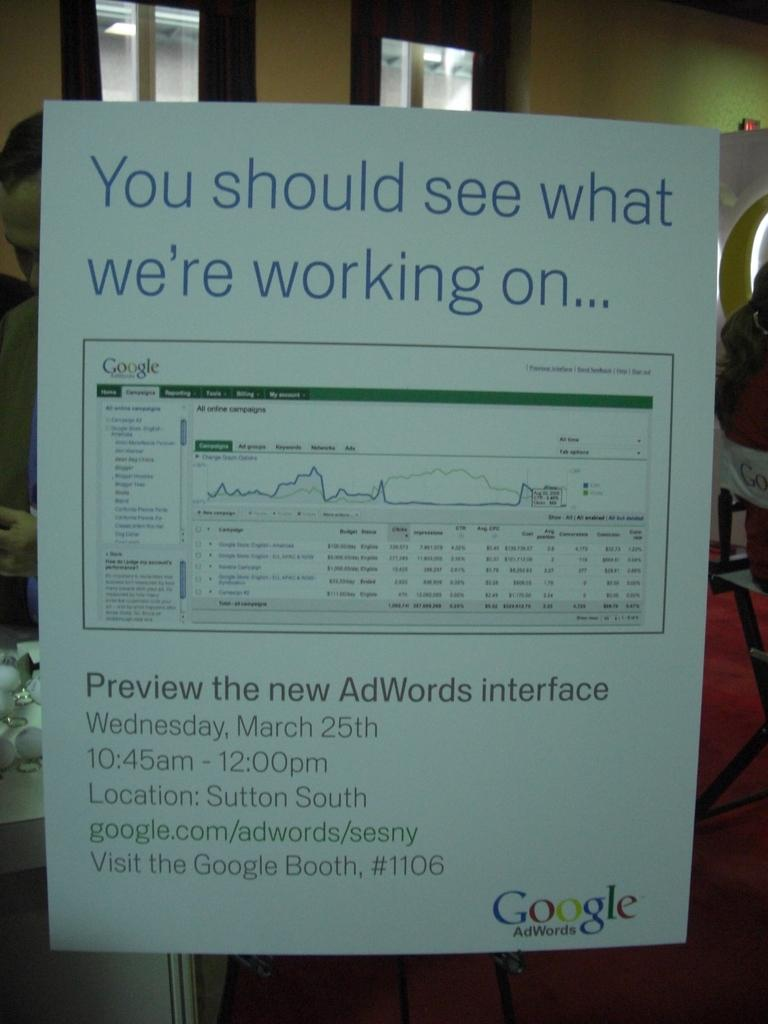<image>
Summarize the visual content of the image. A paper is posted that has Google written in the right corner. 